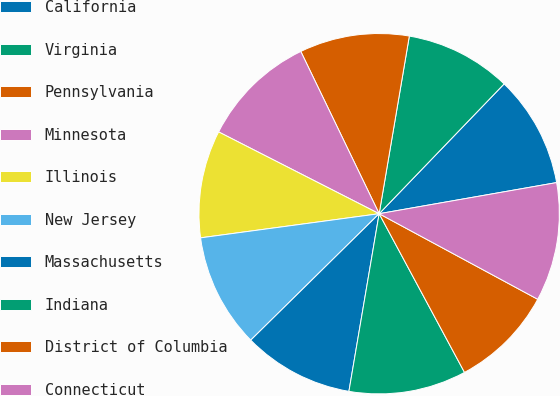Convert chart. <chart><loc_0><loc_0><loc_500><loc_500><pie_chart><fcel>California<fcel>Virginia<fcel>Pennsylvania<fcel>Minnesota<fcel>Illinois<fcel>New Jersey<fcel>Massachusetts<fcel>Indiana<fcel>District of Columbia<fcel>Connecticut<nl><fcel>10.04%<fcel>9.52%<fcel>9.84%<fcel>10.34%<fcel>9.64%<fcel>10.24%<fcel>9.94%<fcel>10.54%<fcel>9.27%<fcel>10.64%<nl></chart> 